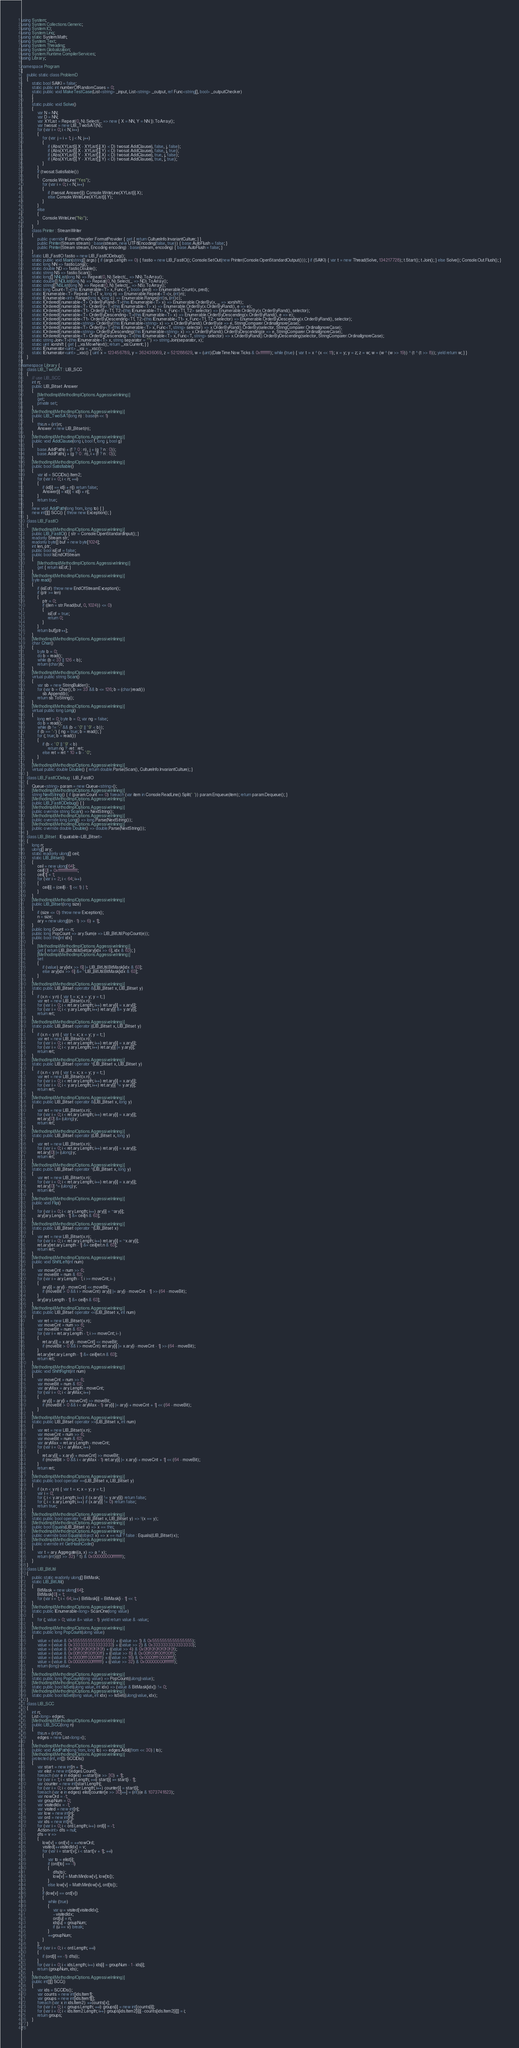<code> <loc_0><loc_0><loc_500><loc_500><_C#_>using System;
using System.Collections.Generic;
using System.IO;
using System.Linq;
using static System.Math;
using System.Text;
using System.Threading;
using System.Globalization;
using System.Runtime.CompilerServices;
using Library;

namespace Program
{
    public static class ProblemD
    {
        static bool SAIKI = false;
        static public int numberOfRandomCases = 0;
        static public void MakeTestCase(List<string> _input, List<string> _output, ref Func<string[], bool> _outputChecker)
        {
        }
        static public void Solve()
        {
            var N = NN;
            var D = NN;
            var XYList = Repeat(0, N).Select(_ => new { X = NN, Y = NN }).ToArray();
            var twosat = new LIB_TwoSAT(N);
            for (var i = 0; i < N; i++)
            {
                for (var j = i + 1; j < N; j++)
                {
                    if (Abs(XYList[i].X - XYList[j].X) < D) twosat.AddClause(i, false, j, false);
                    if (Abs(XYList[i].X - XYList[j].Y) < D) twosat.AddClause(i, false, j, true);
                    if (Abs(XYList[i].Y - XYList[j].X) < D) twosat.AddClause(i, true, j, false);
                    if (Abs(XYList[i].Y - XYList[j].Y) < D) twosat.AddClause(i, true, j, true);
                }
            }
            if (twosat.Satisfiable())
            {
                Console.WriteLine("Yes");
                for (var i = 0; i < N; i++)
                {
                    if (twosat.Answer[i]) Console.WriteLine(XYList[i].X);
                    else Console.WriteLine(XYList[i].Y);
                }
            }
            else
            {
                Console.WriteLine("No");
            }
        }
        class Printer : StreamWriter
        {
            public override IFormatProvider FormatProvider { get { return CultureInfo.InvariantCulture; } }
            public Printer(Stream stream) : base(stream, new UTF8Encoding(false, true)) { base.AutoFlush = false; }
            public Printer(Stream stream, Encoding encoding) : base(stream, encoding) { base.AutoFlush = false; }
        }
        static LIB_FastIO fastio = new LIB_FastIODebug();
        static public void Main(string[] args) { if (args.Length == 0) { fastio = new LIB_FastIO(); Console.SetOut(new Printer(Console.OpenStandardOutput())); } if (SAIKI) { var t = new Thread(Solve, 134217728); t.Start(); t.Join(); } else Solve(); Console.Out.Flush(); }
        static long NN => fastio.Long();
        static double ND => fastio.Double();
        static string NS => fastio.Scan();
        static long[] NNList(long N) => Repeat(0, N).Select(_ => NN).ToArray();
        static double[] NDList(long N) => Repeat(0, N).Select(_ => ND).ToArray();
        static string[] NSList(long N) => Repeat(0, N).Select(_ => NS).ToArray();
        static long Count<T>(this IEnumerable<T> x, Func<T, bool> pred) => Enumerable.Count(x, pred);
        static IEnumerable<T> Repeat<T>(T v, long n) => Enumerable.Repeat<T>(v, (int)n);
        static IEnumerable<int> Range(long s, long c) => Enumerable.Range((int)s, (int)c);
        static IOrderedEnumerable<T> OrderByRand<T>(this IEnumerable<T> x) => Enumerable.OrderBy(x, _ => xorshift);
        static IOrderedEnumerable<T> OrderBy<T>(this IEnumerable<T> x) => Enumerable.OrderBy(x.OrderByRand(), e => e);
        static IOrderedEnumerable<T1> OrderBy<T1, T2>(this IEnumerable<T1> x, Func<T1, T2> selector) => Enumerable.OrderBy(x.OrderByRand(), selector);
        static IOrderedEnumerable<T> OrderByDescending<T>(this IEnumerable<T> x) => Enumerable.OrderByDescending(x.OrderByRand(), e => e);
        static IOrderedEnumerable<T1> OrderByDescending<T1, T2>(this IEnumerable<T1> x, Func<T1, T2> selector) => Enumerable.OrderByDescending(x.OrderByRand(), selector);
        static IOrderedEnumerable<string> OrderBy(this IEnumerable<string> x) => x.OrderByRand().OrderBy(e => e, StringComparer.OrdinalIgnoreCase);
        static IOrderedEnumerable<T> OrderBy<T>(this IEnumerable<T> x, Func<T, string> selector) => x.OrderByRand().OrderBy(selector, StringComparer.OrdinalIgnoreCase);
        static IOrderedEnumerable<string> OrderByDescending(this IEnumerable<string> x) => x.OrderByRand().OrderByDescending(e => e, StringComparer.OrdinalIgnoreCase);
        static IOrderedEnumerable<T> OrderByDescending<T>(this IEnumerable<T> x, Func<T, string> selector) => x.OrderByRand().OrderByDescending(selector, StringComparer.OrdinalIgnoreCase);
        static string Join<T>(this IEnumerable<T> x, string separator = "") => string.Join(separator, x);
        static uint xorshift { get { _xsi.MoveNext(); return _xsi.Current; } }
        static IEnumerator<uint> _xsi = _xsc();
        static IEnumerator<uint> _xsc() { uint x = 123456789, y = 362436069, z = 521288629, w = (uint)(DateTime.Now.Ticks & 0xffffffff); while (true) { var t = x ^ (x << 11); x = y; y = z; z = w; w = (w ^ (w >> 19)) ^ (t ^ (t >> 8)); yield return w; } }
    }
}
namespace Library {
    class LIB_TwoSAT : LIB_SCC
    {
        // use LIB_SCC
        int n;
        public LIB_Bitset Answer
        {
            [MethodImpl(MethodImplOptions.AggressiveInlining)]
            get;
            private set;
        }
        [MethodImpl(MethodImplOptions.AggressiveInlining)]
        public LIB_TwoSAT(long n) : base(n << 1)
        {
            this.n = (int)n;
            Answer = new LIB_Bitset(n);
        }
        [MethodImpl(MethodImplOptions.AggressiveInlining)]
        public void AddClause(long i, bool f, long j, bool g)
        {
            base.AddPath(i + (f ? 0 : n), j + (g ? n : 0));
            base.AddPath(j + (g ? 0 : n), i + (f ? n : 0));
        }
        [MethodImpl(MethodImplOptions.AggressiveInlining)]
        public bool Satisfiable()
        {
            var id = SCCIDs().Item2;
            for (var i = 0; i < n; ++i)
            {
                if (id[i] == id[i + n]) return false;
                Answer[i] = id[i] < id[i + n];
            }
            return true;
        }
        new void AddPath(long from, long to) { }
        new int[][] SCC() { throw new Exception(); }
    }
    class LIB_FastIO
    {
        [MethodImpl(MethodImplOptions.AggressiveInlining)]
        public LIB_FastIO() { str = Console.OpenStandardInput(); }
        readonly Stream str;
        readonly byte[] buf = new byte[1024];
        int len, ptr;
        public bool isEof = false;
        public bool IsEndOfStream
        {
            [MethodImpl(MethodImplOptions.AggressiveInlining)]
            get { return isEof; }
        }
        [MethodImpl(MethodImplOptions.AggressiveInlining)]
        byte read()
        {
            if (isEof) throw new EndOfStreamException();
            if (ptr >= len)
            {
                ptr = 0;
                if ((len = str.Read(buf, 0, 1024)) <= 0)
                {
                    isEof = true;
                    return 0;
                }
            }
            return buf[ptr++];
        }
        [MethodImpl(MethodImplOptions.AggressiveInlining)]
        char Char()
        {
            byte b = 0;
            do b = read();
            while (b < 33 || 126 < b);
            return (char)b;
        }
        [MethodImpl(MethodImplOptions.AggressiveInlining)]
        virtual public string Scan()
        {
            var sb = new StringBuilder();
            for (var b = Char(); b >= 33 && b <= 126; b = (char)read())
                sb.Append(b);
            return sb.ToString();
        }
        [MethodImpl(MethodImplOptions.AggressiveInlining)]
        virtual public long Long()
        {
            long ret = 0; byte b = 0; var ng = false;
            do b = read();
            while (b != '-' && (b < '0' || '9' < b));
            if (b == '-') { ng = true; b = read(); }
            for (; true; b = read())
            {
                if (b < '0' || '9' < b)
                    return ng ? -ret : ret;
                else ret = ret * 10 + b - '0';
            }
        }
        [MethodImpl(MethodImplOptions.AggressiveInlining)]
        virtual public double Double() { return double.Parse(Scan(), CultureInfo.InvariantCulture); }
    }
    class LIB_FastIODebug : LIB_FastIO
    {
        Queue<string> param = new Queue<string>();
        [MethodImpl(MethodImplOptions.AggressiveInlining)]
        string NextString() { if (param.Count == 0) foreach (var item in Console.ReadLine().Split(' ')) param.Enqueue(item); return param.Dequeue(); }
        [MethodImpl(MethodImplOptions.AggressiveInlining)]
        public LIB_FastIODebug() { }
        [MethodImpl(MethodImplOptions.AggressiveInlining)]
        public override string Scan() => NextString();
        [MethodImpl(MethodImplOptions.AggressiveInlining)]
        public override long Long() => long.Parse(NextString());
        [MethodImpl(MethodImplOptions.AggressiveInlining)]
        public override double Double() => double.Parse(NextString());
    }
    class LIB_Bitset : IEquatable<LIB_Bitset>
    {
        long n;
        ulong[] ary;
        static readonly ulong[] ceil;
        static LIB_Bitset()
        {
            ceil = new ulong[64];
            ceil[0] = 0xffffffffffffffff;
            ceil[1] = 1;
            for (var i = 2; i < 64; i++)
            {
                ceil[i] = (ceil[i - 1] << 1) | 1;
            }
        }
        [MethodImpl(MethodImplOptions.AggressiveInlining)]
        public LIB_Bitset(long size)
        {
            if (size <= 0) throw new Exception();
            n = size;
            ary = new ulong[((n - 1) >> 6) + 1];
        }
        public long Count => n;
        public long PopCount => ary.Sum(e => LIB_BitUtil.PopCount(e));
        public bool this[int idx]
        {
            [MethodImpl(MethodImplOptions.AggressiveInlining)]
            get { return LIB_BitUtil.IsSet(ary[idx >> 6], idx & 63); }
            [MethodImpl(MethodImplOptions.AggressiveInlining)]
            set
            {
                if (value) ary[idx >> 6] |= LIB_BitUtil.BitMask[idx & 63];
                else ary[idx >> 6] &= ~LIB_BitUtil.BitMask[idx & 63];
            }
        }
        [MethodImpl(MethodImplOptions.AggressiveInlining)]
        static public LIB_Bitset operator &(LIB_Bitset x, LIB_Bitset y)
        {
            if (x.n < y.n) { var t = x; x = y; y = t; }
            var ret = new LIB_Bitset(x.n);
            for (var i = 0; i < ret.ary.Length; i++) ret.ary[i] = x.ary[i];
            for (var i = 0; i < y.ary.Length; i++) ret.ary[i] &= y.ary[i];
            return ret;
        }
        [MethodImpl(MethodImplOptions.AggressiveInlining)]
        static public LIB_Bitset operator |(LIB_Bitset x, LIB_Bitset y)
        {
            if (x.n < y.n) { var t = x; x = y; y = t; }
            var ret = new LIB_Bitset(x.n);
            for (var i = 0; i < ret.ary.Length; i++) ret.ary[i] = x.ary[i];
            for (var i = 0; i < y.ary.Length; i++) ret.ary[i] |= y.ary[i];
            return ret;
        }
        [MethodImpl(MethodImplOptions.AggressiveInlining)]
        static public LIB_Bitset operator ^(LIB_Bitset x, LIB_Bitset y)
        {
            if (x.n < y.n) { var t = x; x = y; y = t; }
            var ret = new LIB_Bitset(x.n);
            for (var i = 0; i < ret.ary.Length; i++) ret.ary[i] = x.ary[i];
            for (var i = 0; i < y.ary.Length; i++) ret.ary[i] ^= y.ary[i];
            return ret;
        }
        [MethodImpl(MethodImplOptions.AggressiveInlining)]
        static public LIB_Bitset operator &(LIB_Bitset x, long y)
        {
            var ret = new LIB_Bitset(x.n);
            for (var i = 0; i < ret.ary.Length; i++) ret.ary[i] = x.ary[i];
            ret.ary[0] &= (ulong)y;
            return ret;
        }
        [MethodImpl(MethodImplOptions.AggressiveInlining)]
        static public LIB_Bitset operator |(LIB_Bitset x, long y)
        {
            var ret = new LIB_Bitset(x.n);
            for (var i = 0; i < ret.ary.Length; i++) ret.ary[i] = x.ary[i];
            ret.ary[0] |= (ulong)y;
            return ret;
        }
        [MethodImpl(MethodImplOptions.AggressiveInlining)]
        static public LIB_Bitset operator ^(LIB_Bitset x, long y)
        {
            var ret = new LIB_Bitset(x.n);
            for (var i = 0; i < ret.ary.Length; i++) ret.ary[i] = x.ary[i];
            ret.ary[0] ^= (ulong)y;
            return ret;
        }
        [MethodImpl(MethodImplOptions.AggressiveInlining)]
        public void Flip()
        {
            for (var i = 0; i < ary.Length; i++) ary[i] = ~ary[i];
            ary[ary.Length - 1] &= ceil[n & 63];
        }
        [MethodImpl(MethodImplOptions.AggressiveInlining)]
        static public LIB_Bitset operator ~(LIB_Bitset x)
        {
            var ret = new LIB_Bitset(x.n);
            for (var i = 0; i < ret.ary.Length; i++) ret.ary[i] = ~x.ary[i];
            ret.ary[ret.ary.Length - 1] &= ceil[ret.n & 63];
            return ret;
        }
        [MethodImpl(MethodImplOptions.AggressiveInlining)]
        public void ShiftLeft(int num)
        {
            var moveCnt = num >> 6;
            var moveBit = num & 63;
            for (var i = ary.Length - 1; i >= moveCnt; i--)
            {
                ary[i] = ary[i - moveCnt] << moveBit;
                if (moveBit > 0 && i > moveCnt) ary[i] |= ary[i - moveCnt - 1] >> (64 - moveBit);
            }
            ary[ary.Length - 1] &= ceil[n & 63];
        }
        [MethodImpl(MethodImplOptions.AggressiveInlining)]
        static public LIB_Bitset operator <<(LIB_Bitset x, int num)
        {
            var ret = new LIB_Bitset(x.n);
            var moveCnt = num >> 6;
            var moveBit = num & 63;
            for (var i = ret.ary.Length - 1; i >= moveCnt; i--)
            {
                ret.ary[i] = x.ary[i - moveCnt] << moveBit;
                if (moveBit > 0 && i > moveCnt) ret.ary[i] |= x.ary[i - moveCnt - 1] >> (64 - moveBit);
            }
            ret.ary[ret.ary.Length - 1] &= ceil[ret.n & 63];
            return ret;
        }
        [MethodImpl(MethodImplOptions.AggressiveInlining)]
        public void ShiftRight(int num)
        {
            var moveCnt = num >> 6;
            var moveBit = num & 63;
            var aryMax = ary.Length - moveCnt;
            for (var i = 0; i < aryMax; i++)
            {
                ary[i] = ary[i + moveCnt] >> moveBit;
                if (moveBit > 0 && i < aryMax - 1) ary[i] |= ary[i + moveCnt + 1] << (64 - moveBit);
            }
        }
        [MethodImpl(MethodImplOptions.AggressiveInlining)]
        static public LIB_Bitset operator >>(LIB_Bitset x, int num)
        {
            var ret = new LIB_Bitset(x.n);
            var moveCnt = num >> 6;
            var moveBit = num & 63;
            var aryMax = ret.ary.Length - moveCnt;
            for (var i = 0; i < aryMax; i++)
            {
                ret.ary[i] = x.ary[i + moveCnt] >> moveBit;
                if (moveBit > 0 && i < aryMax - 1) ret.ary[i] |= x.ary[i + moveCnt + 1] << (64 - moveBit);
            }
            return ret;
        }
        [MethodImpl(MethodImplOptions.AggressiveInlining)]
        static public bool operator ==(LIB_Bitset x, LIB_Bitset y)
        {
            if (x.n < y.n) { var t = x; x = y; y = t; }
            var i = 0;
            for (; i < y.ary.Length; i++) if (x.ary[i] != y.ary[i]) return false;
            for (; i < x.ary.Length; i++) if (x.ary[i] != 0) return false;
            return true;
        }
        [MethodImpl(MethodImplOptions.AggressiveInlining)]
        static public bool operator !=(LIB_Bitset x, LIB_Bitset y) => !(x == y);
        [MethodImpl(MethodImplOptions.AggressiveInlining)]
        public bool Equals(LIB_Bitset x) => x == this;
        [MethodImpl(MethodImplOptions.AggressiveInlining)]
        public override bool Equals(object x) => x == null ? false : Equals((LIB_Bitset)x);
        [MethodImpl(MethodImplOptions.AggressiveInlining)]
        public override int GetHashCode()
        {
            var t = ary.Aggregate((a, x) => a ^ x);
            return (int)(((t >> 32) ^ t) & 0x00000000ffffffff);
        }
    }
    class LIB_BitUtil
    {
        public static readonly ulong[] BitMask;
        static LIB_BitUtil()
        {
            BitMask = new ulong[64];
            BitMask[0] = 1;
            for (var i = 1; i < 64; i++) BitMask[i] = BitMask[i - 1] << 1;
        }
        [MethodImpl(MethodImplOptions.AggressiveInlining)]
        static public IEnumerable<long> ScanOne(long value)
        {
            for (; value > 0; value &= value - 1) yield return value & -value;
        }
        [MethodImpl(MethodImplOptions.AggressiveInlining)]
        static public long PopCount(ulong value)
        {
            value = (value & 0x5555555555555555) + ((value >> 1) & 0x5555555555555555);
            value = (value & 0x3333333333333333) + ((value >> 2) & 0x3333333333333333);
            value = (value & 0x0f0f0f0f0f0f0f0f) + ((value >> 4) & 0x0f0f0f0f0f0f0f0f);
            value = (value & 0x00ff00ff00ff00ff) + ((value >> 8) & 0x00ff00ff00ff00ff);
            value = (value & 0x0000ffff0000ffff) + ((value >> 16) & 0x0000ffff0000ffff);
            value = (value & 0x00000000ffffffff) + ((value >> 32) & 0x00000000ffffffff);
            return (long)value;
        }
        [MethodImpl(MethodImplOptions.AggressiveInlining)]
        static public long PopCount(long value) => PopCount((ulong)value);
        [MethodImpl(MethodImplOptions.AggressiveInlining)]
        static public bool IsSet(ulong value, int idx) => (value & BitMask[idx]) != 0;
        [MethodImpl(MethodImplOptions.AggressiveInlining)]
        static public bool IsSet(long value, int idx) => IsSet((ulong)value, idx);
    }
    class LIB_SCC
    {
        int n;
        List<long> edges;
        [MethodImpl(MethodImplOptions.AggressiveInlining)]
        public LIB_SCC(long n)
        {
            this.n = (int)n;
            edges = new List<long>();
        }
        [MethodImpl(MethodImplOptions.AggressiveInlining)]
        public void AddPath(long from, long to) => edges.Add((from << 30) | to);
        [MethodImpl(MethodImplOptions.AggressiveInlining)]
        protected (int, int[]) SCCIDs()
        {
            var start = new int[n + 1];
            var elist = new int[edges.Count];
            foreach (var e in edges) ++start[(e >> 30) + 1];
            for (var i = 1; i < start.Length; ++i) start[i] += start[i - 1];
            var counter = new int[start.Length];
            for (var i = 0; i < counter.Length; i++) counter[i] = start[i];
            foreach (var e in edges) elist[counter[e >> 30]++] = (int)(e & 1073741823);
            var nowOrd = -1;
            var groupNum = 0;
            var visitedIdx = -1;
            var visited = new int[n];
            var low = new int[n];
            var ord = new int[n];
            var ids = new int[n];
            for (var i = 0; i < ord.Length; i++) ord[i] = -1;
            Action<int> dfs = null;
            dfs = v =>
            {
                low[v] = ord[v] = ++nowOrd;
                visited[++visitedIdx] = v;
                for (var i = start[v]; i < start[v + 1]; ++i)
                {
                    var to = elist[i];
                    if (ord[to] == -1)
                    {
                        dfs(to);
                        low[v] = Math.Min(low[v], low[to]);
                    }
                    else low[v] = Math.Min(low[v], ord[to]);
                }
                if (low[v] == ord[v])
                {
                    while (true)
                    {
                        var u = visited[visitedIdx];
                        --visitedIdx;
                        ord[u] = n;
                        ids[u] = groupNum;
                        if (u == v) break;
                    }
                    ++groupNum;
                }
            };
            for (var i = 0; i < ord.Length; ++i)
            {
                if (ord[i] == -1) dfs(i);
            }
            for (var i = 0; i < ids.Length; i++) ids[i] = groupNum - 1 - ids[i];
            return (groupNum, ids);
        }
        [MethodImpl(MethodImplOptions.AggressiveInlining)]
        public int[][] SCC()
        {
            var ids = SCCIDs();
            var counts = new int[ids.Item1];
            var groups = new int[ids.Item1][];
            foreach (var x in ids.Item2) ++counts[x];
            for (var i = 0; i < groups.Length; ++i) groups[i] = new int[counts[i]];
            for (var i = 0; i < ids.Item2.Length; i++) groups[ids.Item2[i]][--counts[ids.Item2[i]]] = i;
            return groups;
        }
    }
}
</code> 